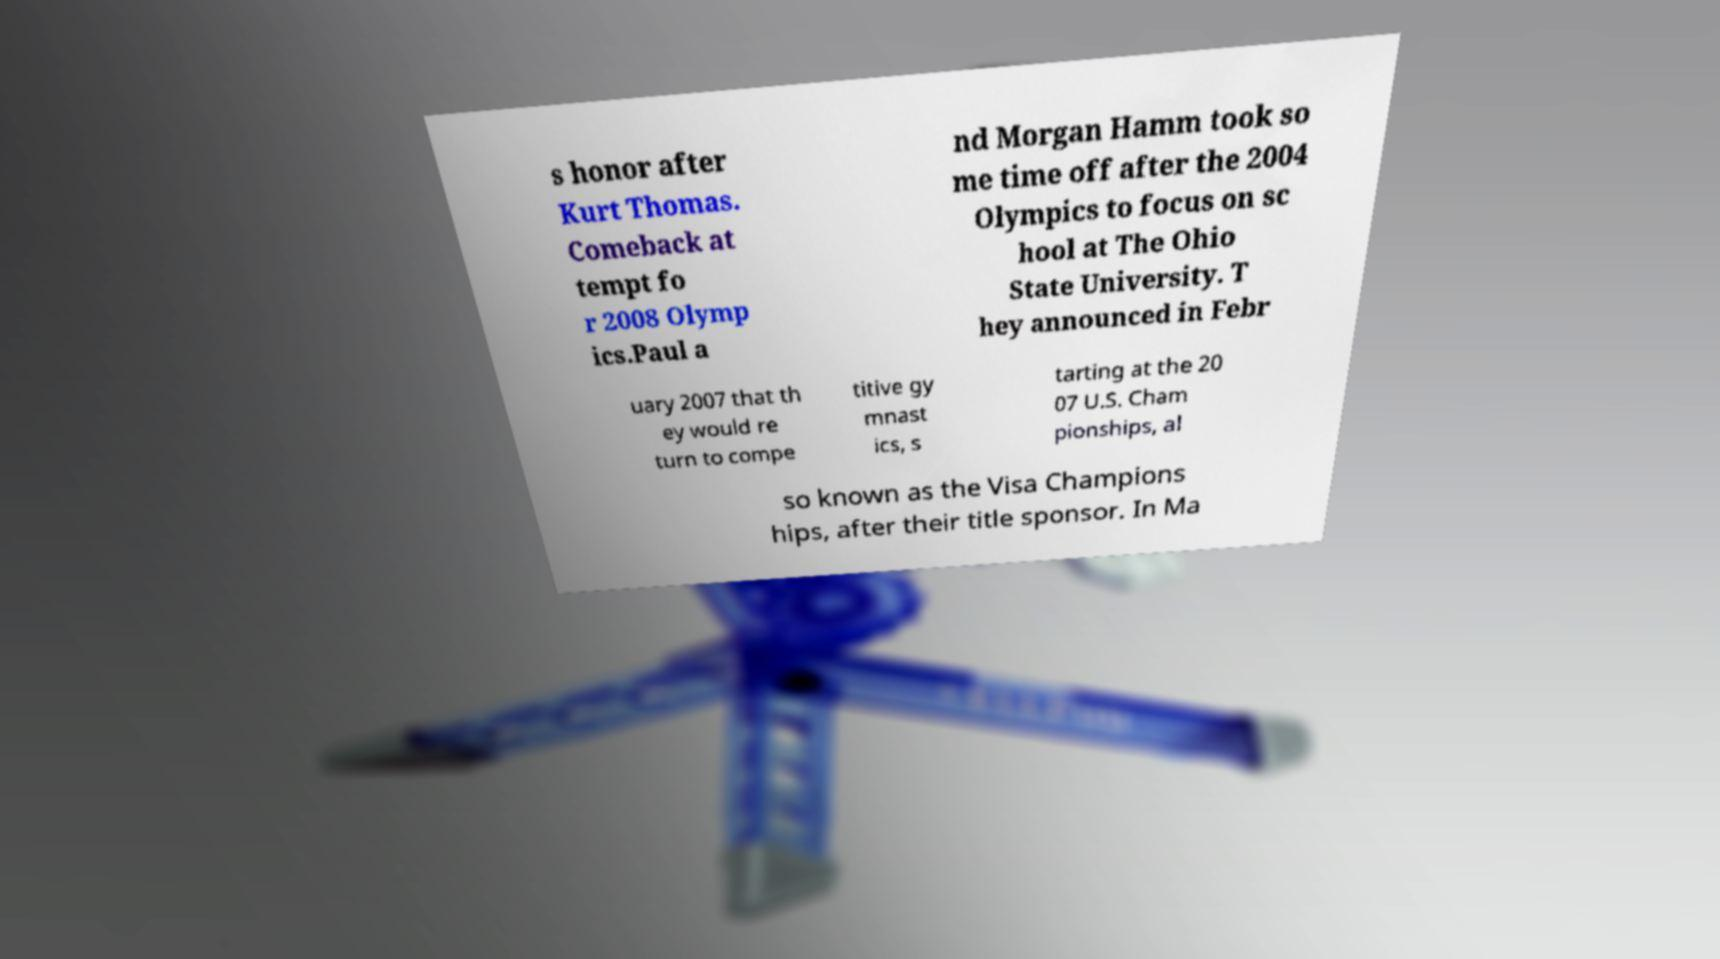Can you accurately transcribe the text from the provided image for me? s honor after Kurt Thomas. Comeback at tempt fo r 2008 Olymp ics.Paul a nd Morgan Hamm took so me time off after the 2004 Olympics to focus on sc hool at The Ohio State University. T hey announced in Febr uary 2007 that th ey would re turn to compe titive gy mnast ics, s tarting at the 20 07 U.S. Cham pionships, al so known as the Visa Champions hips, after their title sponsor. In Ma 